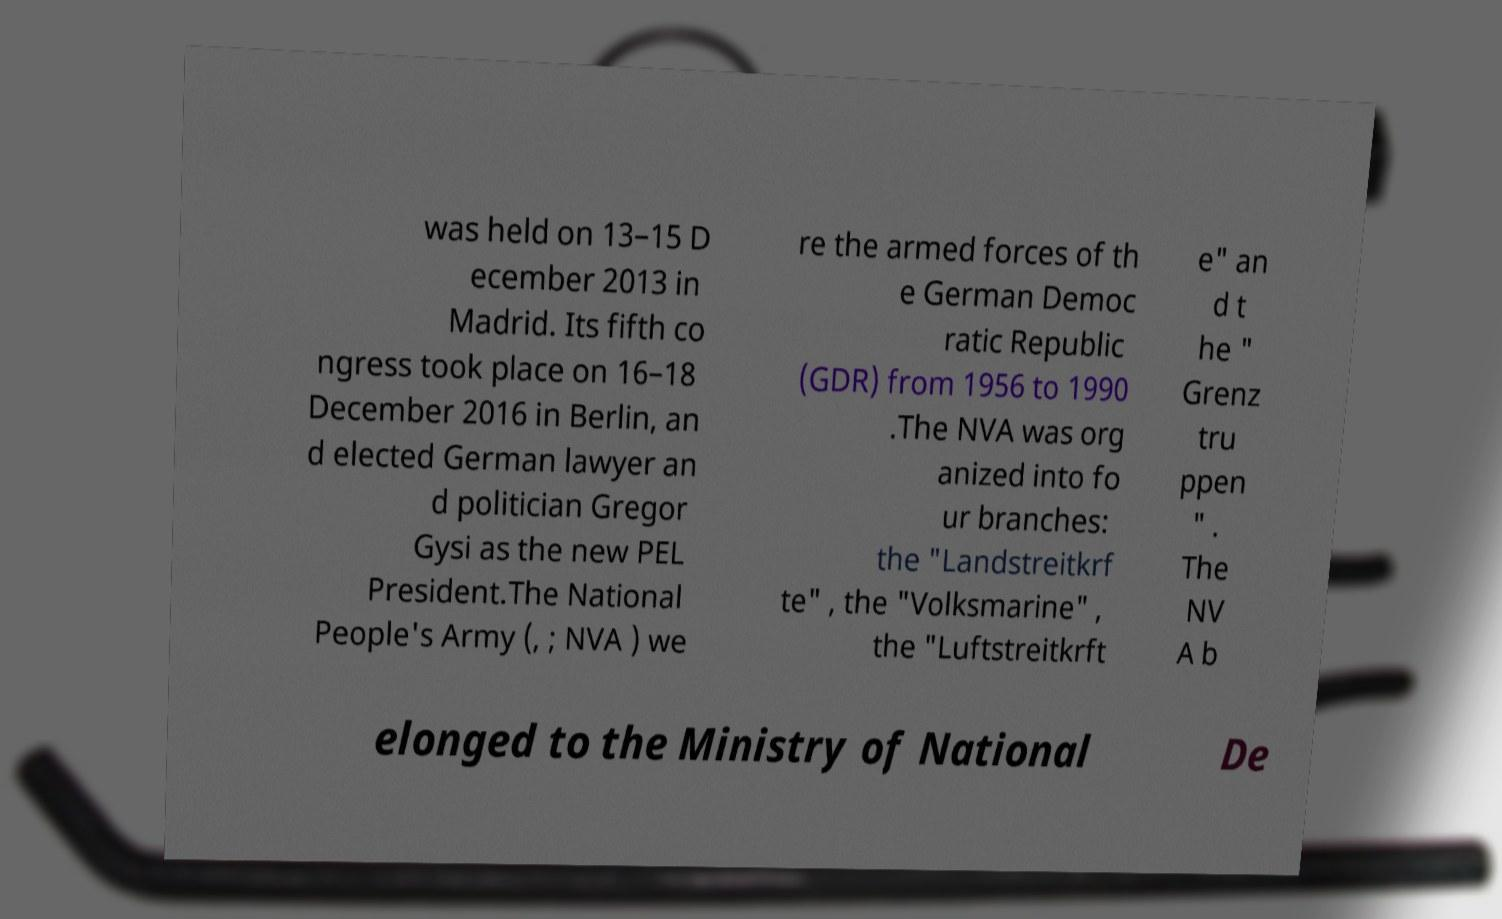Can you read and provide the text displayed in the image?This photo seems to have some interesting text. Can you extract and type it out for me? was held on 13–15 D ecember 2013 in Madrid. Its fifth co ngress took place on 16–18 December 2016 in Berlin, an d elected German lawyer an d politician Gregor Gysi as the new PEL President.The National People's Army (, ; NVA ) we re the armed forces of th e German Democ ratic Republic (GDR) from 1956 to 1990 .The NVA was org anized into fo ur branches: the "Landstreitkrf te" , the "Volksmarine" , the "Luftstreitkrft e" an d t he " Grenz tru ppen " . The NV A b elonged to the Ministry of National De 